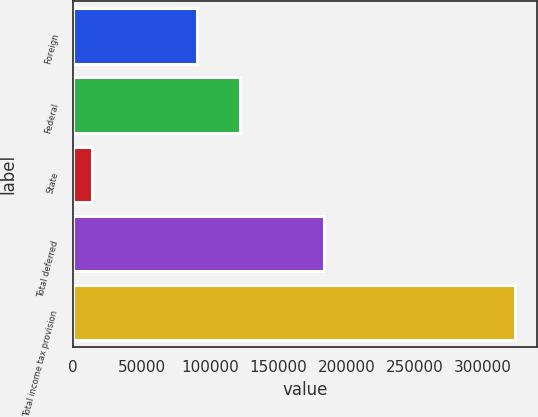<chart> <loc_0><loc_0><loc_500><loc_500><bar_chart><fcel>Foreign<fcel>Federal<fcel>State<fcel>Total deferred<fcel>Total income tax provision<nl><fcel>90877<fcel>121764<fcel>14073<fcel>183770<fcel>322940<nl></chart> 